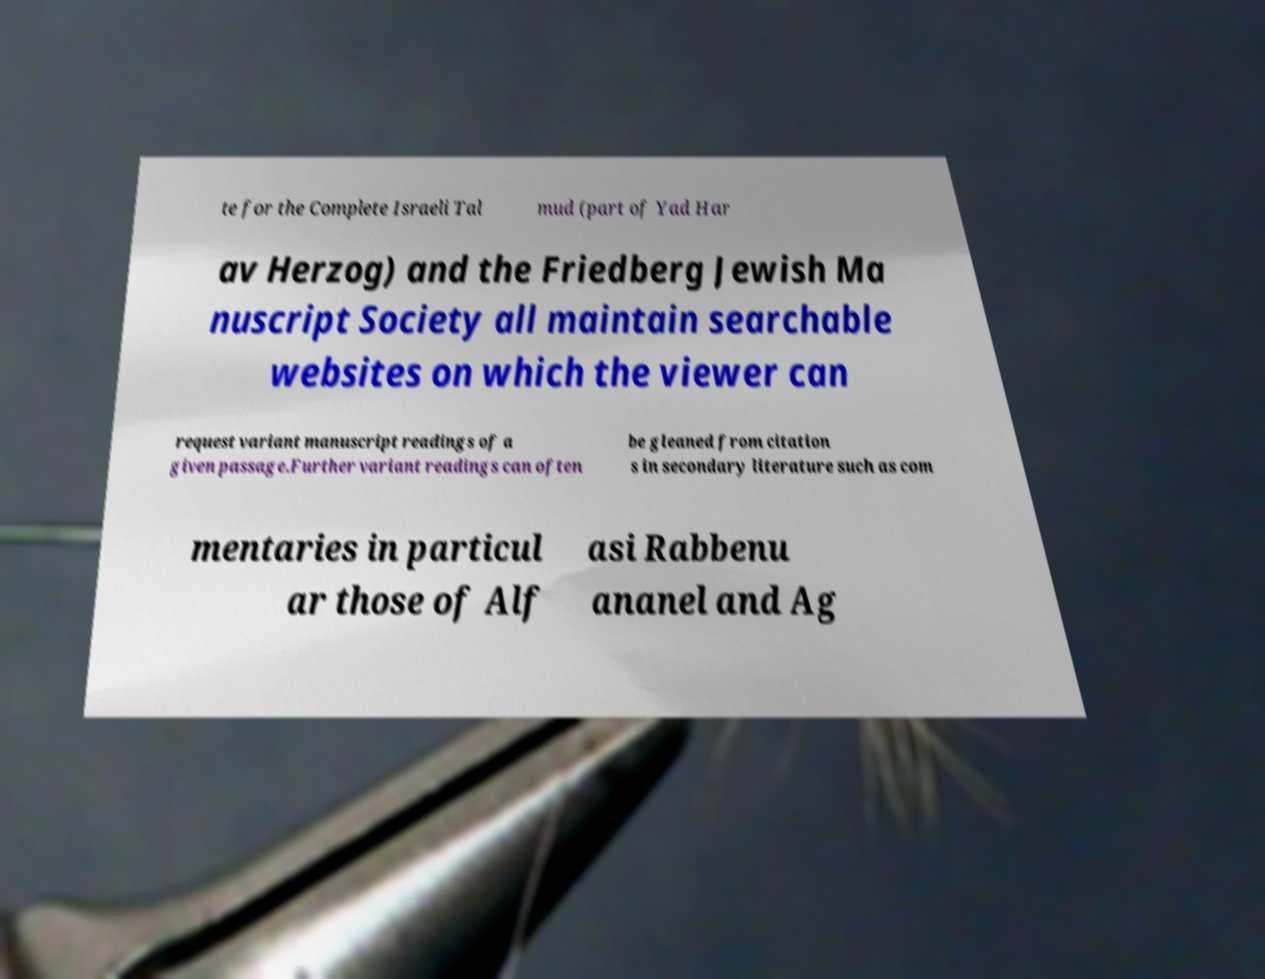I need the written content from this picture converted into text. Can you do that? te for the Complete Israeli Tal mud (part of Yad Har av Herzog) and the Friedberg Jewish Ma nuscript Society all maintain searchable websites on which the viewer can request variant manuscript readings of a given passage.Further variant readings can often be gleaned from citation s in secondary literature such as com mentaries in particul ar those of Alf asi Rabbenu ananel and Ag 